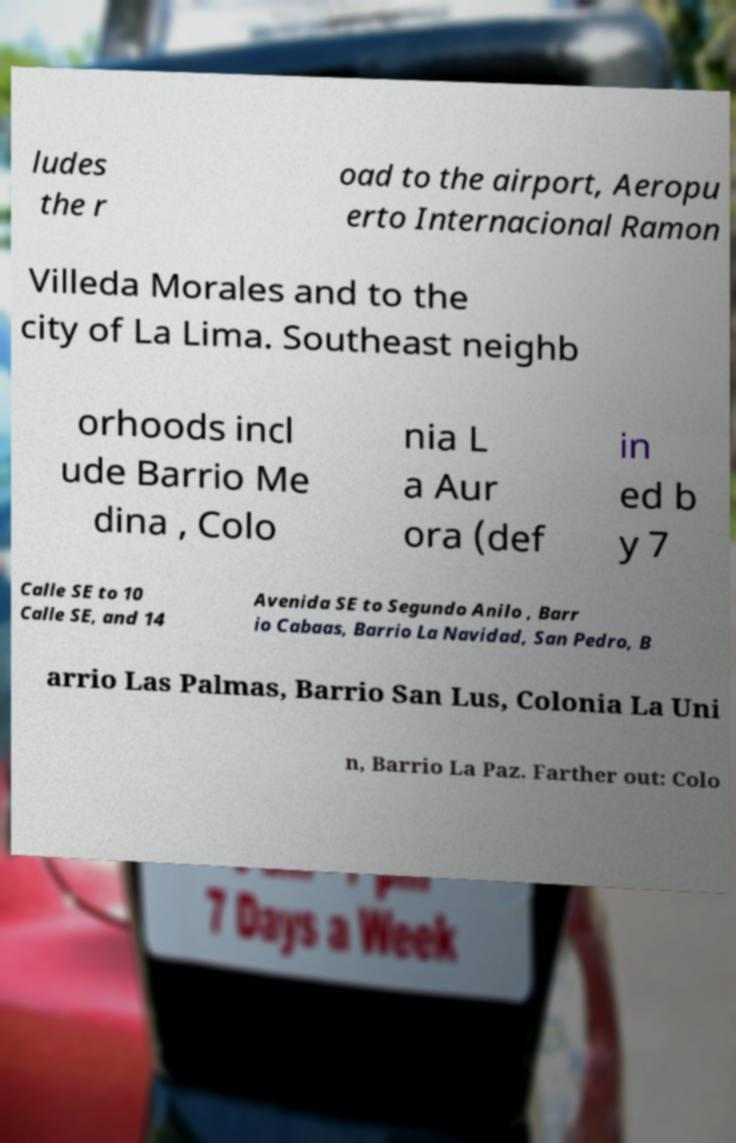Can you accurately transcribe the text from the provided image for me? ludes the r oad to the airport, Aeropu erto Internacional Ramon Villeda Morales and to the city of La Lima. Southeast neighb orhoods incl ude Barrio Me dina , Colo nia L a Aur ora (def in ed b y 7 Calle SE to 10 Calle SE, and 14 Avenida SE to Segundo Anilo , Barr io Cabaas, Barrio La Navidad, San Pedro, B arrio Las Palmas, Barrio San Lus, Colonia La Uni n, Barrio La Paz. Farther out: Colo 